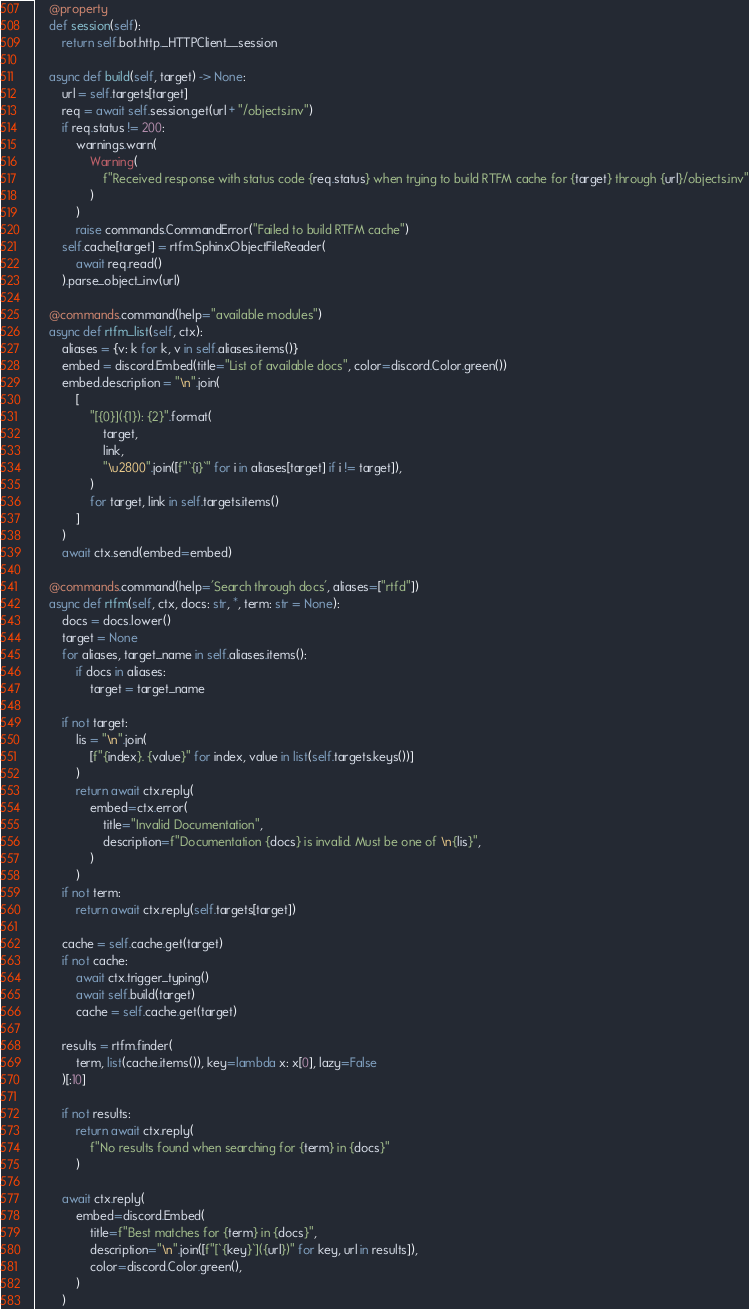<code> <loc_0><loc_0><loc_500><loc_500><_Python_>    @property
    def session(self):
        return self.bot.http._HTTPClient__session

    async def build(self, target) -> None:
        url = self.targets[target]
        req = await self.session.get(url + "/objects.inv")
        if req.status != 200:
            warnings.warn(
                Warning(
                    f"Received response with status code {req.status} when trying to build RTFM cache for {target} through {url}/objects.inv"
                )
            )
            raise commands.CommandError("Failed to build RTFM cache")
        self.cache[target] = rtfm.SphinxObjectFileReader(
            await req.read()
        ).parse_object_inv(url)

    @commands.command(help="available modules")
    async def rtfm_list(self, ctx):
        aliases = {v: k for k, v in self.aliases.items()}
        embed = discord.Embed(title="List of available docs", color=discord.Color.green())
        embed.description = "\n".join(
            [
                "[{0}]({1}): {2}".format(
                    target,
                    link,
                    "\u2800".join([f"`{i}`" for i in aliases[target] if i != target]),
                )
                for target, link in self.targets.items()
            ]
        )
        await ctx.send(embed=embed)

    @commands.command(help='Search through docs', aliases=["rtfd"])
    async def rtfm(self, ctx, docs: str, *, term: str = None):
        docs = docs.lower()
        target = None
        for aliases, target_name in self.aliases.items():
            if docs in aliases:
                target = target_name

        if not target:
            lis = "\n".join(
                [f"{index}. {value}" for index, value in list(self.targets.keys())]
            )
            return await ctx.reply(
                embed=ctx.error(
                    title="Invalid Documentation",
                    description=f"Documentation {docs} is invalid. Must be one of \n{lis}",
                )
            )
        if not term:
            return await ctx.reply(self.targets[target])

        cache = self.cache.get(target)
        if not cache:
            await ctx.trigger_typing()
            await self.build(target)
            cache = self.cache.get(target)

        results = rtfm.finder(
            term, list(cache.items()), key=lambda x: x[0], lazy=False
        )[:10]

        if not results:
            return await ctx.reply(
                f"No results found when searching for {term} in {docs}"
            )

        await ctx.reply(
            embed=discord.Embed(
                title=f"Best matches for {term} in {docs}",
                description="\n".join([f"[`{key}`]({url})" for key, url in results]),
                color=discord.Color.green(),
            )
        )</code> 